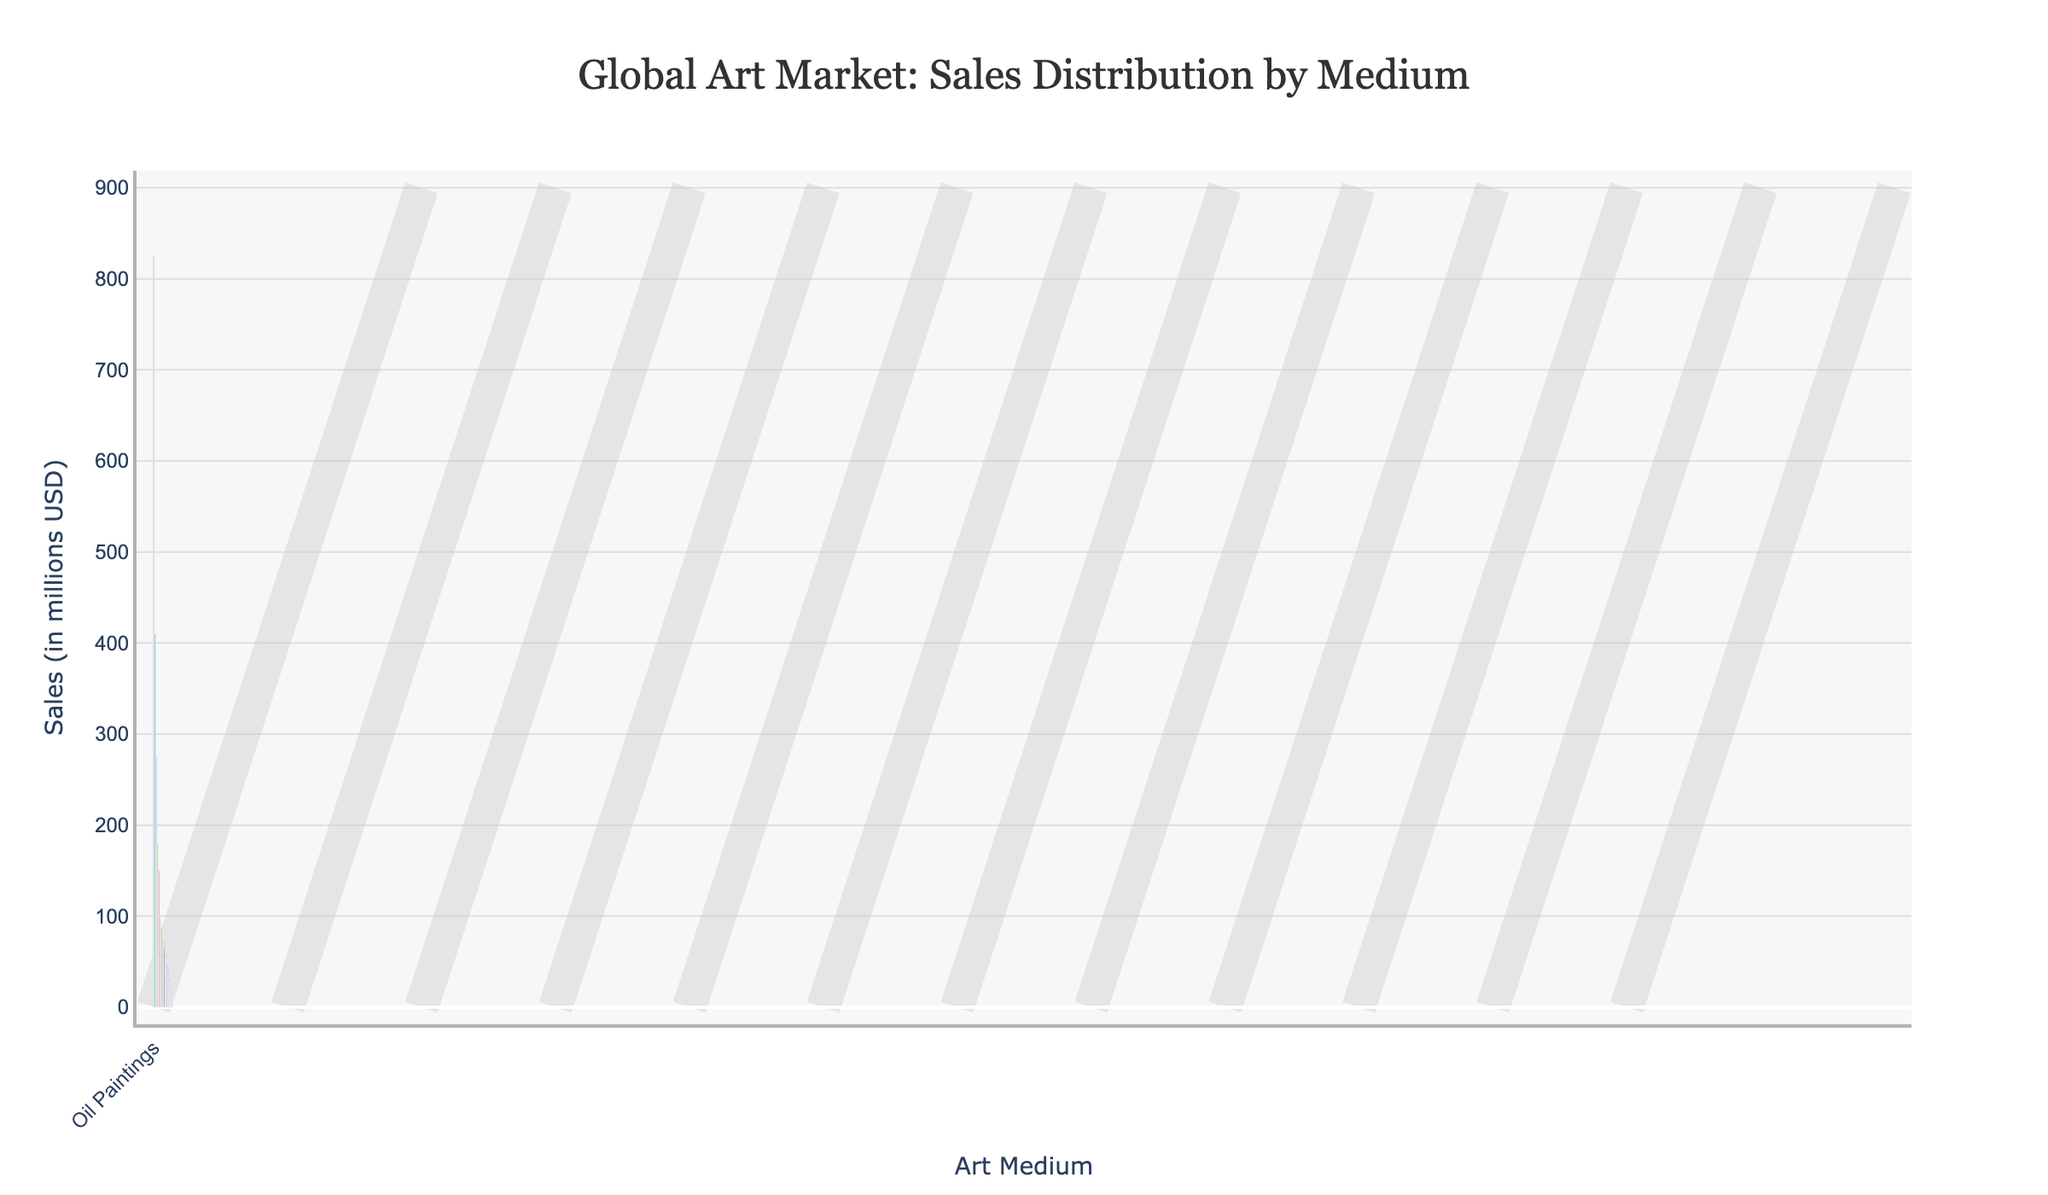Which art medium has the highest sales? The bar representing the 'Oil Paintings' is the tallest, indicating the highest sales among all art mediums.
Answer: Oil Paintings What is the total sales value of Digital Art and Charcoal combined? From the chart, the sales for Digital Art are 150 million USD and for Charcoal, it is 45 million USD. Adding these gives 150 + 45 = 195 million USD.
Answer: 195 million USD How much higher are sales for Acrylic Paintings compared to Watercolors? The chart shows Acrylic Paintings have sales of 410 million USD and Watercolors 275 million USD. The difference is 410 - 275 = 135 million USD.
Answer: 135 million USD Which art medium has slightly higher sales: Spray Paint or Collage? The bar for Spray Paint shows sales of 85 million USD, while the bar for Collage shows 70 million USD. Therefore, Spray Paint has higher sales.
Answer: Spray Paint Arrange the top three highest-selling art mediums in descending order. The top three highest sales are represented by the tallest bars: Oil Paintings (825 million USD), Acrylic Paintings (410 million USD), and Watercolors (275 million USD).
Answer: Oil Paintings, Acrylic Paintings, Watercolors What is the visual difference between the sales of Pastels and Gouache? Pastels have sales of 95 million USD, shown by a taller bar compared to Gouache, which has sales of 65 million USD. This visual height difference corresponds to a difference of 95 - 65 = 30 million USD.
Answer: Pastels have 30 million USD more in sales than Gouache What are the combined sales of the lowest three art mediums? The lowest sales are shown for Egg Tempera (15 million USD), Fresco (20 million USD), and Tempera (30 million USD). Their combined sales are 15 + 20 + 30 = 65 million USD.
Answer: 65 million USD Compare the sales of Mixed Media to Digital Art. Which one has higher sales? Mixed Media has sales of 180 million USD, as shown by the height of its bar, compared to Digital Art which has sales of 150 million USD. Hence, Mixed Media has higher sales.
Answer: Mixed Media What is the average sales value of Watercolors, Ink Wash, and Spray Paint? The sales for Watercolors are 275 million USD, Ink Wash 55 million USD, and Spray Paint 85 million USD. Summing these gives 275 + 55 + 85 = 415 million USD, and the average is 415 / 3 = ~138.33 million USD.
Answer: ~138.33 million USD 